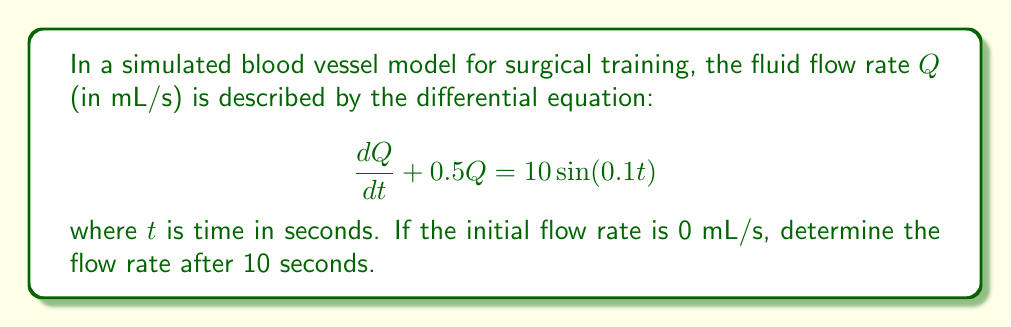Can you solve this math problem? To solve this problem, we need to follow these steps:

1) The given differential equation is a first-order linear differential equation of the form:

   $$\frac{dQ}{dt} + PQ = R$$

   where $P = 0.5$ and $R = 10\sin(0.1t)$

2) The general solution for this type of equation is:

   $$Q = e^{-\int P dt} \left(\int Re^{\int P dt}dt + C\right)$$

3) First, let's calculate $\int P dt$:

   $$\int P dt = \int 0.5 dt = 0.5t$$

4) Now, our solution becomes:

   $$Q = e^{-0.5t} \left(\int 10\sin(0.1t)e^{0.5t}dt + C\right)$$

5) To solve the integral, we use integration by parts twice:

   $$\int 10\sin(0.1t)e^{0.5t}dt = 10e^{0.5t}\left(\frac{0.5\sin(0.1t) - 0.1\cos(0.1t)}{0.26}\right) + K$$

6) Substituting this back into our solution:

   $$Q = e^{-0.5t} \left(10e^{0.5t}\left(\frac{0.5\sin(0.1t) - 0.1\cos(0.1t)}{0.26}\right) + C\right)$$

   $$Q = \frac{10}{0.26}(0.5\sin(0.1t) - 0.1\cos(0.1t)) + Ce^{-0.5t}$$

7) To find $C$, we use the initial condition $Q(0) = 0$:

   $$0 = \frac{10}{0.26}(0 - 0.1) + C$$
   $$C = \frac{1}{0.26}$$

8) Our final solution is:

   $$Q = \frac{10}{0.26}(0.5\sin(0.1t) - 0.1\cos(0.1t)) + \frac{1}{0.26}e^{-0.5t}$$

9) To find $Q(10)$, we substitute $t = 10$:

   $$Q(10) = \frac{10}{0.26}(0.5\sin(1) - 0.1\cos(1)) + \frac{1}{0.26}e^{-5}$$

10) Calculating this:

    $$Q(10) \approx 16.37 \text{ mL/s}$$
Answer: 16.37 mL/s 